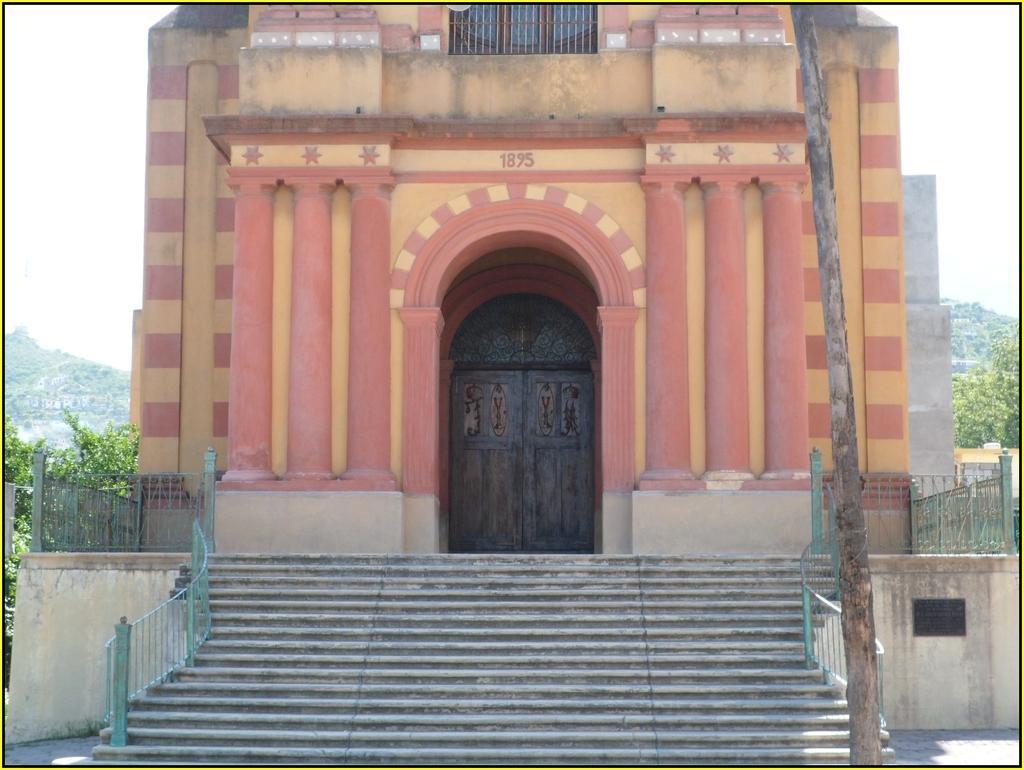Describe this image in one or two sentences. This a photo. In the center of the image we can see a building, door, pillars, text, window. In the background of the image the hills, trees, railing, stairs. At the bottom of the image we can see the floor. At the top of the image we can see the sky. On the right side of the image we can see a pole. 